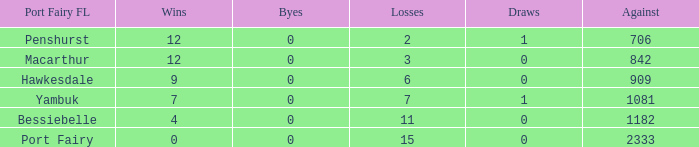What is the number of byes when the draws are below 0? 0.0. 